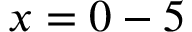<formula> <loc_0><loc_0><loc_500><loc_500>x = 0 - 5</formula> 